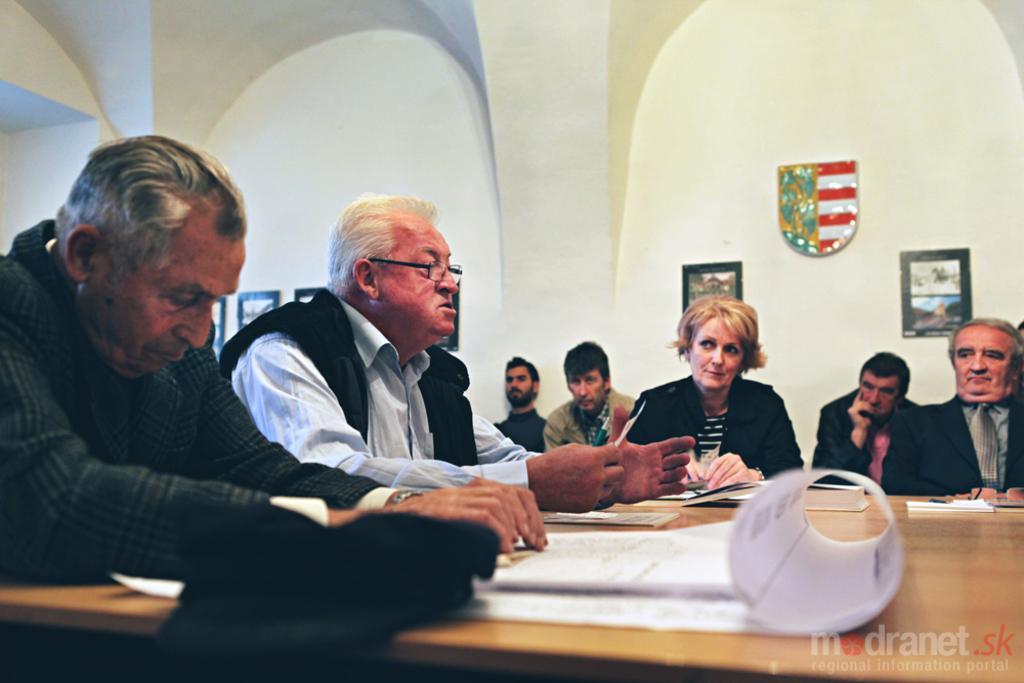How would you summarize this image in a sentence or two? At the bottom of the image there is a table. On the table there are papers and also there is a book. Behind the table there are few people sitting. In the background there is a wall with frames. In the bottom right corner of the image there is a watermark. 